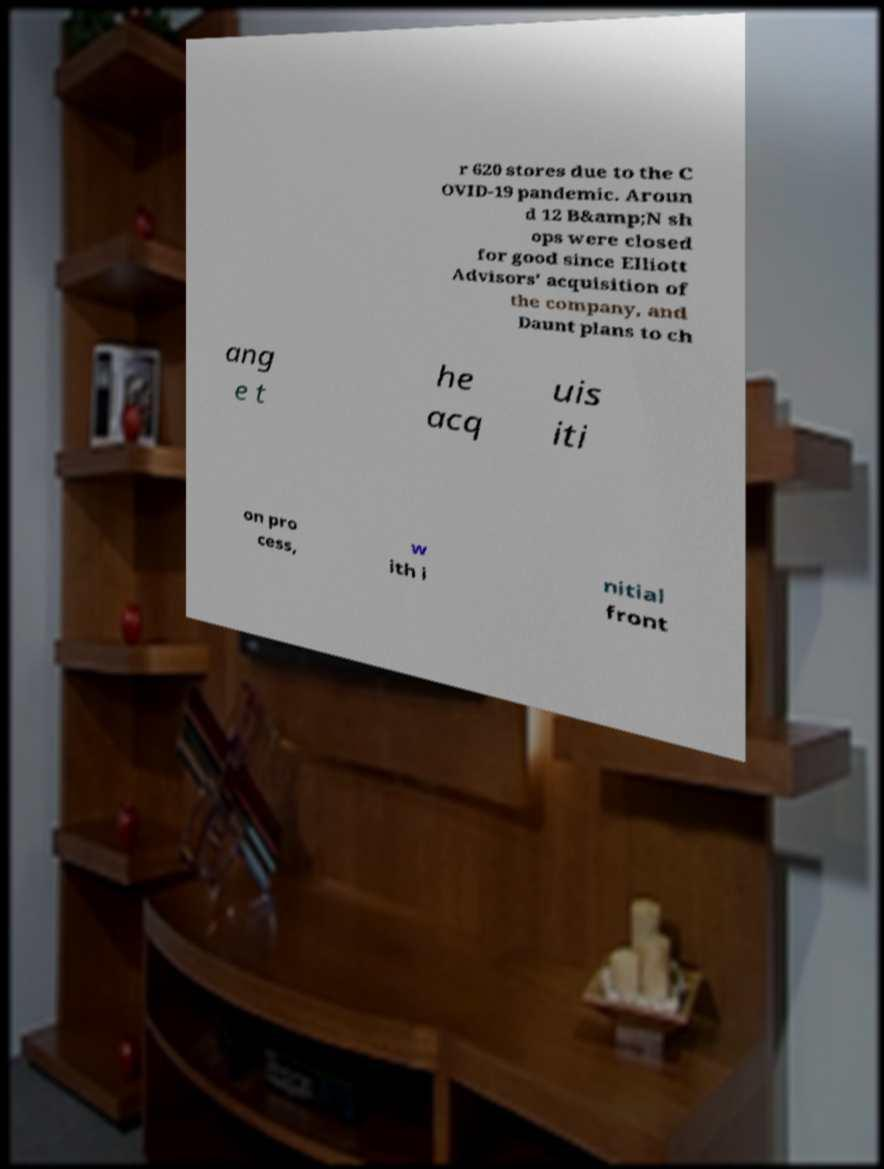I need the written content from this picture converted into text. Can you do that? r 620 stores due to the C OVID-19 pandemic. Aroun d 12 B&amp;N sh ops were closed for good since Elliott Advisors' acquisition of the company, and Daunt plans to ch ang e t he acq uis iti on pro cess, w ith i nitial front 